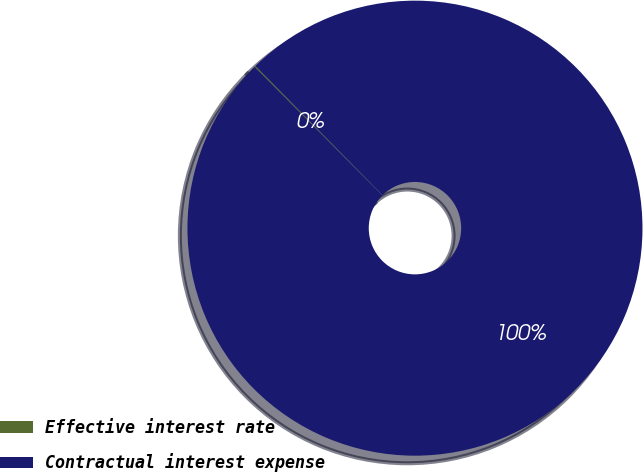Convert chart to OTSL. <chart><loc_0><loc_0><loc_500><loc_500><pie_chart><fcel>Effective interest rate<fcel>Contractual interest expense<nl><fcel>0.09%<fcel>99.91%<nl></chart> 